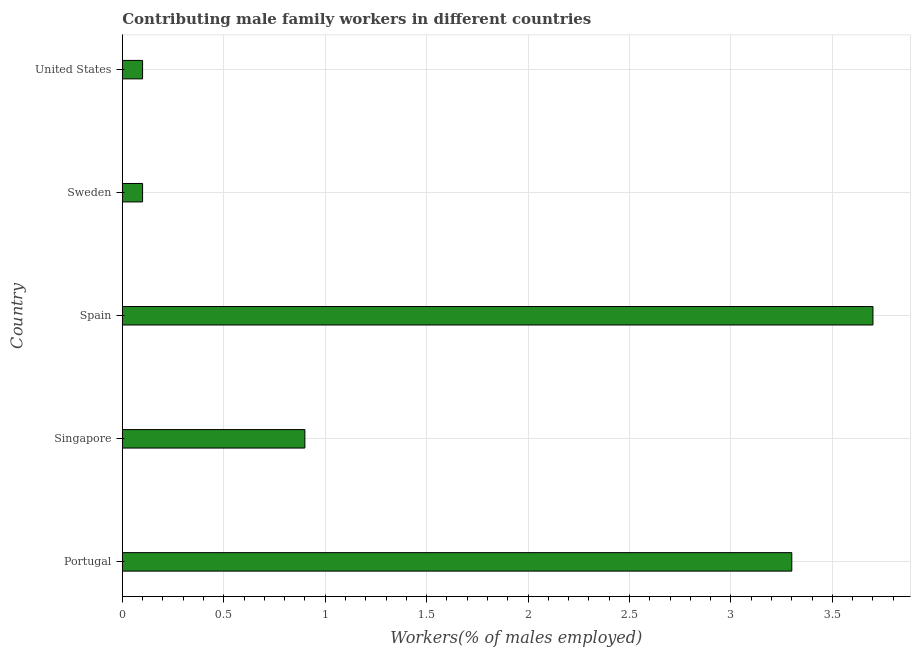What is the title of the graph?
Provide a short and direct response. Contributing male family workers in different countries. What is the label or title of the X-axis?
Offer a very short reply. Workers(% of males employed). What is the contributing male family workers in United States?
Provide a short and direct response. 0.1. Across all countries, what is the maximum contributing male family workers?
Ensure brevity in your answer.  3.7. Across all countries, what is the minimum contributing male family workers?
Keep it short and to the point. 0.1. In which country was the contributing male family workers maximum?
Offer a terse response. Spain. In which country was the contributing male family workers minimum?
Provide a short and direct response. Sweden. What is the sum of the contributing male family workers?
Your response must be concise. 8.1. What is the average contributing male family workers per country?
Provide a succinct answer. 1.62. What is the median contributing male family workers?
Keep it short and to the point. 0.9. What is the difference between the highest and the second highest contributing male family workers?
Make the answer very short. 0.4. Is the sum of the contributing male family workers in Portugal and United States greater than the maximum contributing male family workers across all countries?
Your answer should be very brief. No. In how many countries, is the contributing male family workers greater than the average contributing male family workers taken over all countries?
Give a very brief answer. 2. How many countries are there in the graph?
Offer a terse response. 5. What is the Workers(% of males employed) of Portugal?
Make the answer very short. 3.3. What is the Workers(% of males employed) of Singapore?
Offer a terse response. 0.9. What is the Workers(% of males employed) of Spain?
Make the answer very short. 3.7. What is the Workers(% of males employed) of Sweden?
Your answer should be compact. 0.1. What is the Workers(% of males employed) in United States?
Your answer should be very brief. 0.1. What is the difference between the Workers(% of males employed) in Portugal and Sweden?
Provide a succinct answer. 3.2. What is the difference between the Workers(% of males employed) in Portugal and United States?
Ensure brevity in your answer.  3.2. What is the difference between the Workers(% of males employed) in Singapore and Sweden?
Your response must be concise. 0.8. What is the difference between the Workers(% of males employed) in Singapore and United States?
Offer a very short reply. 0.8. What is the difference between the Workers(% of males employed) in Spain and Sweden?
Provide a succinct answer. 3.6. What is the difference between the Workers(% of males employed) in Sweden and United States?
Ensure brevity in your answer.  0. What is the ratio of the Workers(% of males employed) in Portugal to that in Singapore?
Keep it short and to the point. 3.67. What is the ratio of the Workers(% of males employed) in Portugal to that in Spain?
Keep it short and to the point. 0.89. What is the ratio of the Workers(% of males employed) in Portugal to that in Sweden?
Your response must be concise. 33. What is the ratio of the Workers(% of males employed) in Portugal to that in United States?
Keep it short and to the point. 33. What is the ratio of the Workers(% of males employed) in Singapore to that in Spain?
Provide a short and direct response. 0.24. What is the ratio of the Workers(% of males employed) in Singapore to that in Sweden?
Offer a very short reply. 9. What is the ratio of the Workers(% of males employed) in Sweden to that in United States?
Give a very brief answer. 1. 